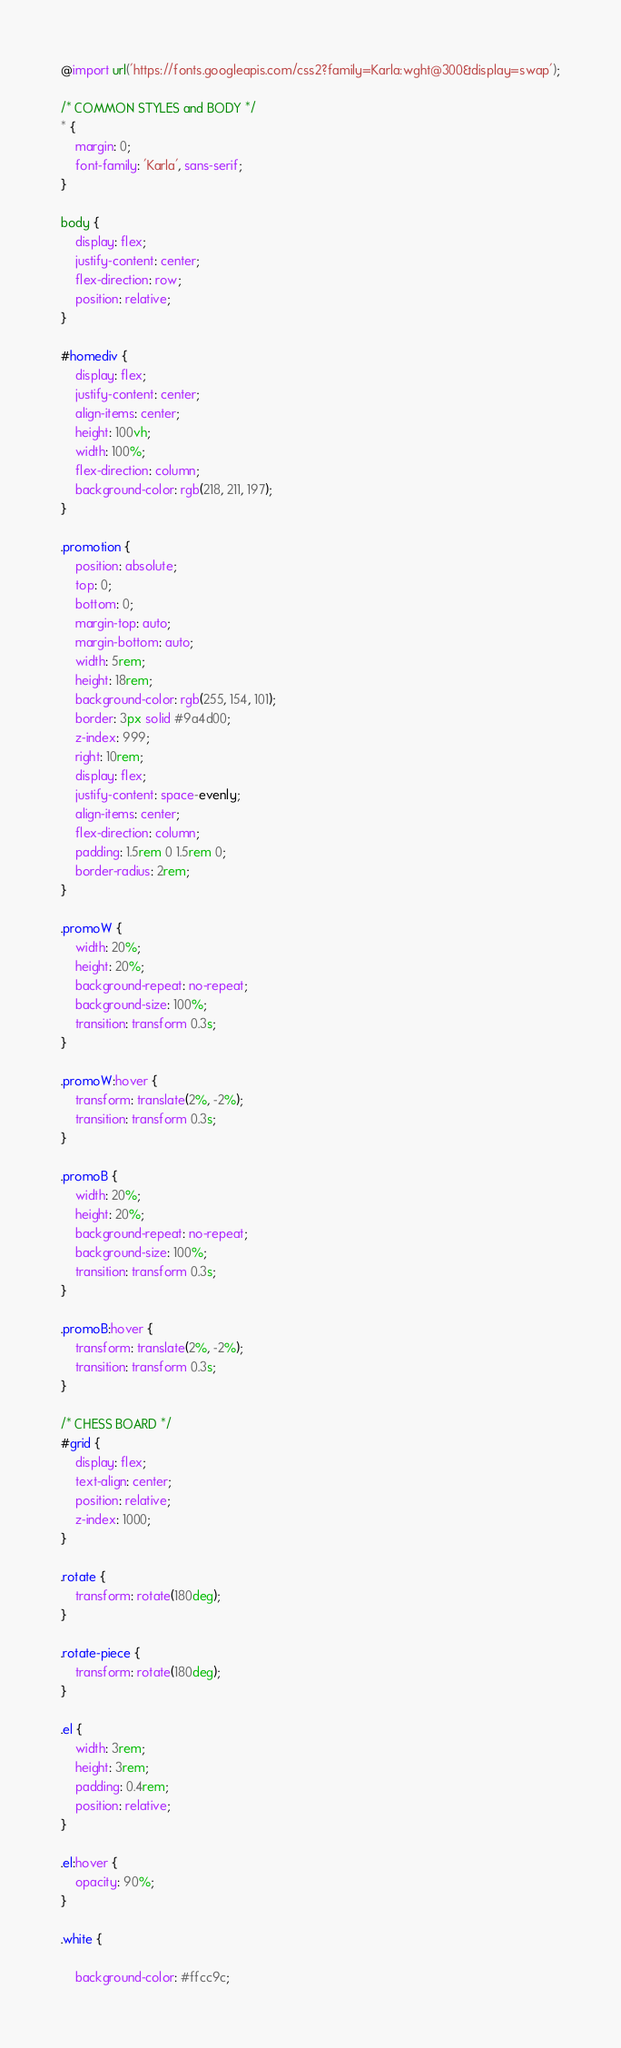Convert code to text. <code><loc_0><loc_0><loc_500><loc_500><_CSS_>@import url('https://fonts.googleapis.com/css2?family=Karla:wght@300&display=swap');

/* COMMON STYLES and BODY */
* {
    margin: 0;
    font-family: 'Karla', sans-serif;
}

body {
    display: flex;
    justify-content: center;
    flex-direction: row;
    position: relative;
}

#homediv {
    display: flex;
    justify-content: center;
    align-items: center;
    height: 100vh;
    width: 100%;
    flex-direction: column;
    background-color: rgb(218, 211, 197);
}

.promotion {
    position: absolute;
    top: 0;
    bottom: 0;
    margin-top: auto;
    margin-bottom: auto;
    width: 5rem;
    height: 18rem;
    background-color: rgb(255, 154, 101);
    border: 3px solid #9a4d00;
    z-index: 999;
    right: 10rem;
    display: flex;
    justify-content: space-evenly;
    align-items: center;
    flex-direction: column;
    padding: 1.5rem 0 1.5rem 0;
    border-radius: 2rem;
}

.promoW {
    width: 20%;
    height: 20%;
    background-repeat: no-repeat;
    background-size: 100%;
    transition: transform 0.3s;
}

.promoW:hover {
    transform: translate(2%, -2%);
    transition: transform 0.3s;
}

.promoB {
    width: 20%;
    height: 20%;
    background-repeat: no-repeat;
    background-size: 100%;
    transition: transform 0.3s;
}

.promoB:hover {
    transform: translate(2%, -2%);
    transition: transform 0.3s;
}

/* CHESS BOARD */
#grid {
    display: flex;
    text-align: center;
    position: relative;
    z-index: 1000;
}

.rotate {
    transform: rotate(180deg);
}

.rotate-piece {
    transform: rotate(180deg);
}

.el {
    width: 3rem;
    height: 3rem;
    padding: 0.4rem;
    position: relative;
}

.el:hover {
    opacity: 90%;
}

.white {

    background-color: #ffcc9c;</code> 